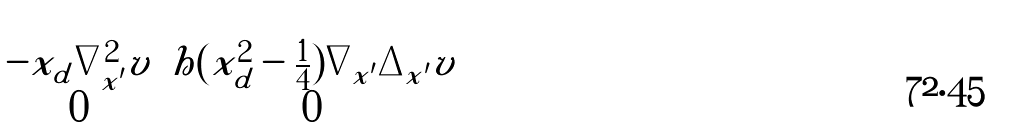<formula> <loc_0><loc_0><loc_500><loc_500>\begin{pmatrix} - x _ { d } \nabla _ { x ^ { \prime } } ^ { 2 } v & h ( x _ { d } ^ { 2 } - \frac { 1 } { 4 } ) \nabla _ { x ^ { \prime } } \Delta _ { x ^ { \prime } } v \\ 0 & 0 \end{pmatrix}</formula> 